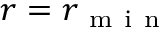<formula> <loc_0><loc_0><loc_500><loc_500>r = r _ { m i n }</formula> 